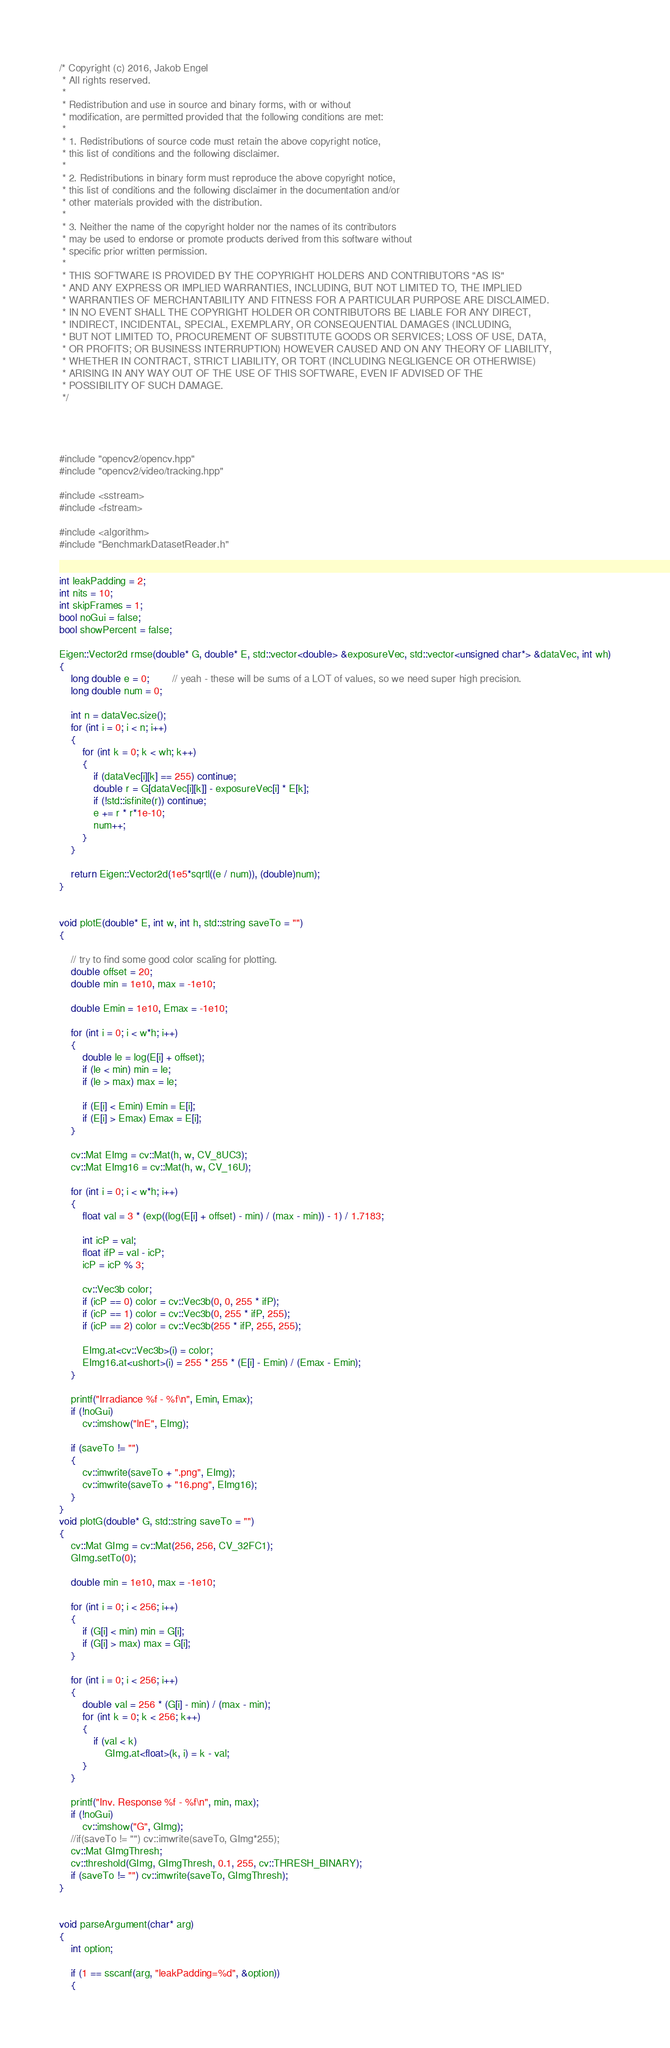Convert code to text. <code><loc_0><loc_0><loc_500><loc_500><_C++_>/* Copyright (c) 2016, Jakob Engel
 * All rights reserved.
 *
 * Redistribution and use in source and binary forms, with or without
 * modification, are permitted provided that the following conditions are met:
 *
 * 1. Redistributions of source code must retain the above copyright notice,
 * this list of conditions and the following disclaimer.
 *
 * 2. Redistributions in binary form must reproduce the above copyright notice,
 * this list of conditions and the following disclaimer in the documentation and/or
 * other materials provided with the distribution.
 *
 * 3. Neither the name of the copyright holder nor the names of its contributors
 * may be used to endorse or promote products derived from this software without
 * specific prior written permission.
 *
 * THIS SOFTWARE IS PROVIDED BY THE COPYRIGHT HOLDERS AND CONTRIBUTORS "AS IS"
 * AND ANY EXPRESS OR IMPLIED WARRANTIES, INCLUDING, BUT NOT LIMITED TO, THE IMPLIED
 * WARRANTIES OF MERCHANTABILITY AND FITNESS FOR A PARTICULAR PURPOSE ARE DISCLAIMED.
 * IN NO EVENT SHALL THE COPYRIGHT HOLDER OR CONTRIBUTORS BE LIABLE FOR ANY DIRECT,
 * INDIRECT, INCIDENTAL, SPECIAL, EXEMPLARY, OR CONSEQUENTIAL DAMAGES (INCLUDING,
 * BUT NOT LIMITED TO, PROCUREMENT OF SUBSTITUTE GOODS OR SERVICES; LOSS OF USE, DATA,
 * OR PROFITS; OR BUSINESS INTERRUPTION) HOWEVER CAUSED AND ON ANY THEORY OF LIABILITY,
 * WHETHER IN CONTRACT, STRICT LIABILITY, OR TORT (INCLUDING NEGLIGENCE OR OTHERWISE)
 * ARISING IN ANY WAY OUT OF THE USE OF THIS SOFTWARE, EVEN IF ADVISED OF THE
 * POSSIBILITY OF SUCH DAMAGE.
 */




#include "opencv2/opencv.hpp"
#include "opencv2/video/tracking.hpp"

#include <sstream>
#include <fstream>

#include <algorithm>
#include "BenchmarkDatasetReader.h"


int leakPadding = 2;
int nits = 10;
int skipFrames = 1;
bool noGui = false;
bool showPercent = false;

Eigen::Vector2d rmse(double* G, double* E, std::vector<double> &exposureVec, std::vector<unsigned char*> &dataVec, int wh)
{
	long double e = 0;		// yeah - these will be sums of a LOT of values, so we need super high precision.
	long double num = 0;

	int n = dataVec.size();
	for (int i = 0; i < n; i++)
	{
		for (int k = 0; k < wh; k++)
		{
			if (dataVec[i][k] == 255) continue;
			double r = G[dataVec[i][k]] - exposureVec[i] * E[k];
			if (!std::isfinite(r)) continue;
			e += r * r*1e-10;
			num++;
		}
	}

	return Eigen::Vector2d(1e5*sqrtl((e / num)), (double)num);
}


void plotE(double* E, int w, int h, std::string saveTo = "")
{

	// try to find some good color scaling for plotting.
	double offset = 20;
	double min = 1e10, max = -1e10;

	double Emin = 1e10, Emax = -1e10;

	for (int i = 0; i < w*h; i++)
	{
		double le = log(E[i] + offset);
		if (le < min) min = le;
		if (le > max) max = le;

		if (E[i] < Emin) Emin = E[i];
		if (E[i] > Emax) Emax = E[i];
	}

	cv::Mat EImg = cv::Mat(h, w, CV_8UC3);
	cv::Mat EImg16 = cv::Mat(h, w, CV_16U);

	for (int i = 0; i < w*h; i++)
	{
		float val = 3 * (exp((log(E[i] + offset) - min) / (max - min)) - 1) / 1.7183;

		int icP = val;
		float ifP = val - icP;
		icP = icP % 3;

		cv::Vec3b color;
		if (icP == 0) color = cv::Vec3b(0, 0, 255 * ifP);
		if (icP == 1) color = cv::Vec3b(0, 255 * ifP, 255);
		if (icP == 2) color = cv::Vec3b(255 * ifP, 255, 255);

		EImg.at<cv::Vec3b>(i) = color;
		EImg16.at<ushort>(i) = 255 * 255 * (E[i] - Emin) / (Emax - Emin);
	}

	printf("Irradiance %f - %f\n", Emin, Emax);
	if (!noGui)
		cv::imshow("lnE", EImg);

	if (saveTo != "")
	{
		cv::imwrite(saveTo + ".png", EImg);
		cv::imwrite(saveTo + "16.png", EImg16);
	}
}
void plotG(double* G, std::string saveTo = "")
{
	cv::Mat GImg = cv::Mat(256, 256, CV_32FC1);
	GImg.setTo(0);

	double min = 1e10, max = -1e10;

	for (int i = 0; i < 256; i++)
	{
		if (G[i] < min) min = G[i];
		if (G[i] > max) max = G[i];
	}

	for (int i = 0; i < 256; i++)
	{
		double val = 256 * (G[i] - min) / (max - min);
		for (int k = 0; k < 256; k++)
		{
			if (val < k)
				GImg.at<float>(k, i) = k - val;
		}
	}

	printf("Inv. Response %f - %f\n", min, max);
	if (!noGui)
		cv::imshow("G", GImg);
	//if(saveTo != "") cv::imwrite(saveTo, GImg*255);
	cv::Mat GImgThresh;
	cv::threshold(GImg, GImgThresh, 0.1, 255, cv::THRESH_BINARY);
	if (saveTo != "") cv::imwrite(saveTo, GImgThresh);
}


void parseArgument(char* arg)
{
	int option;

	if (1 == sscanf(arg, "leakPadding=%d", &option))
	{</code> 